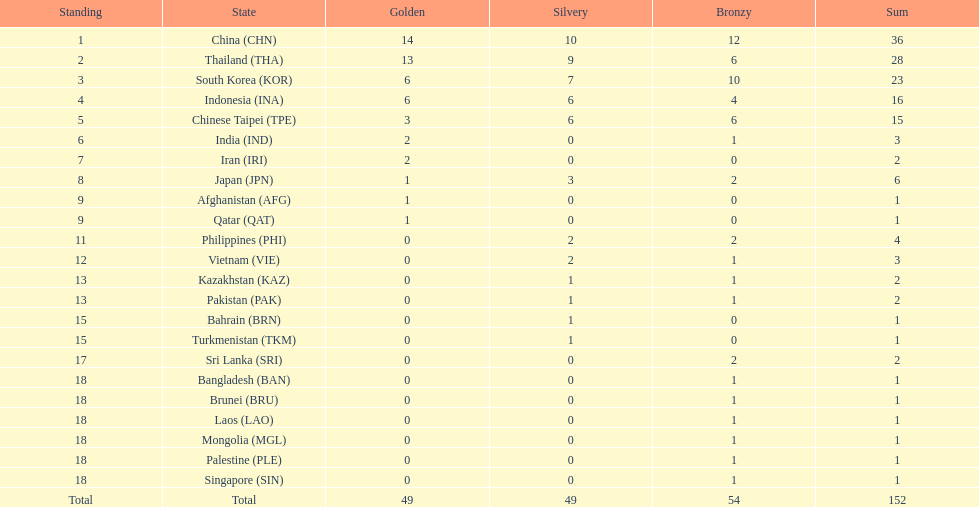How many more medals did india earn compared to pakistan? 1. 